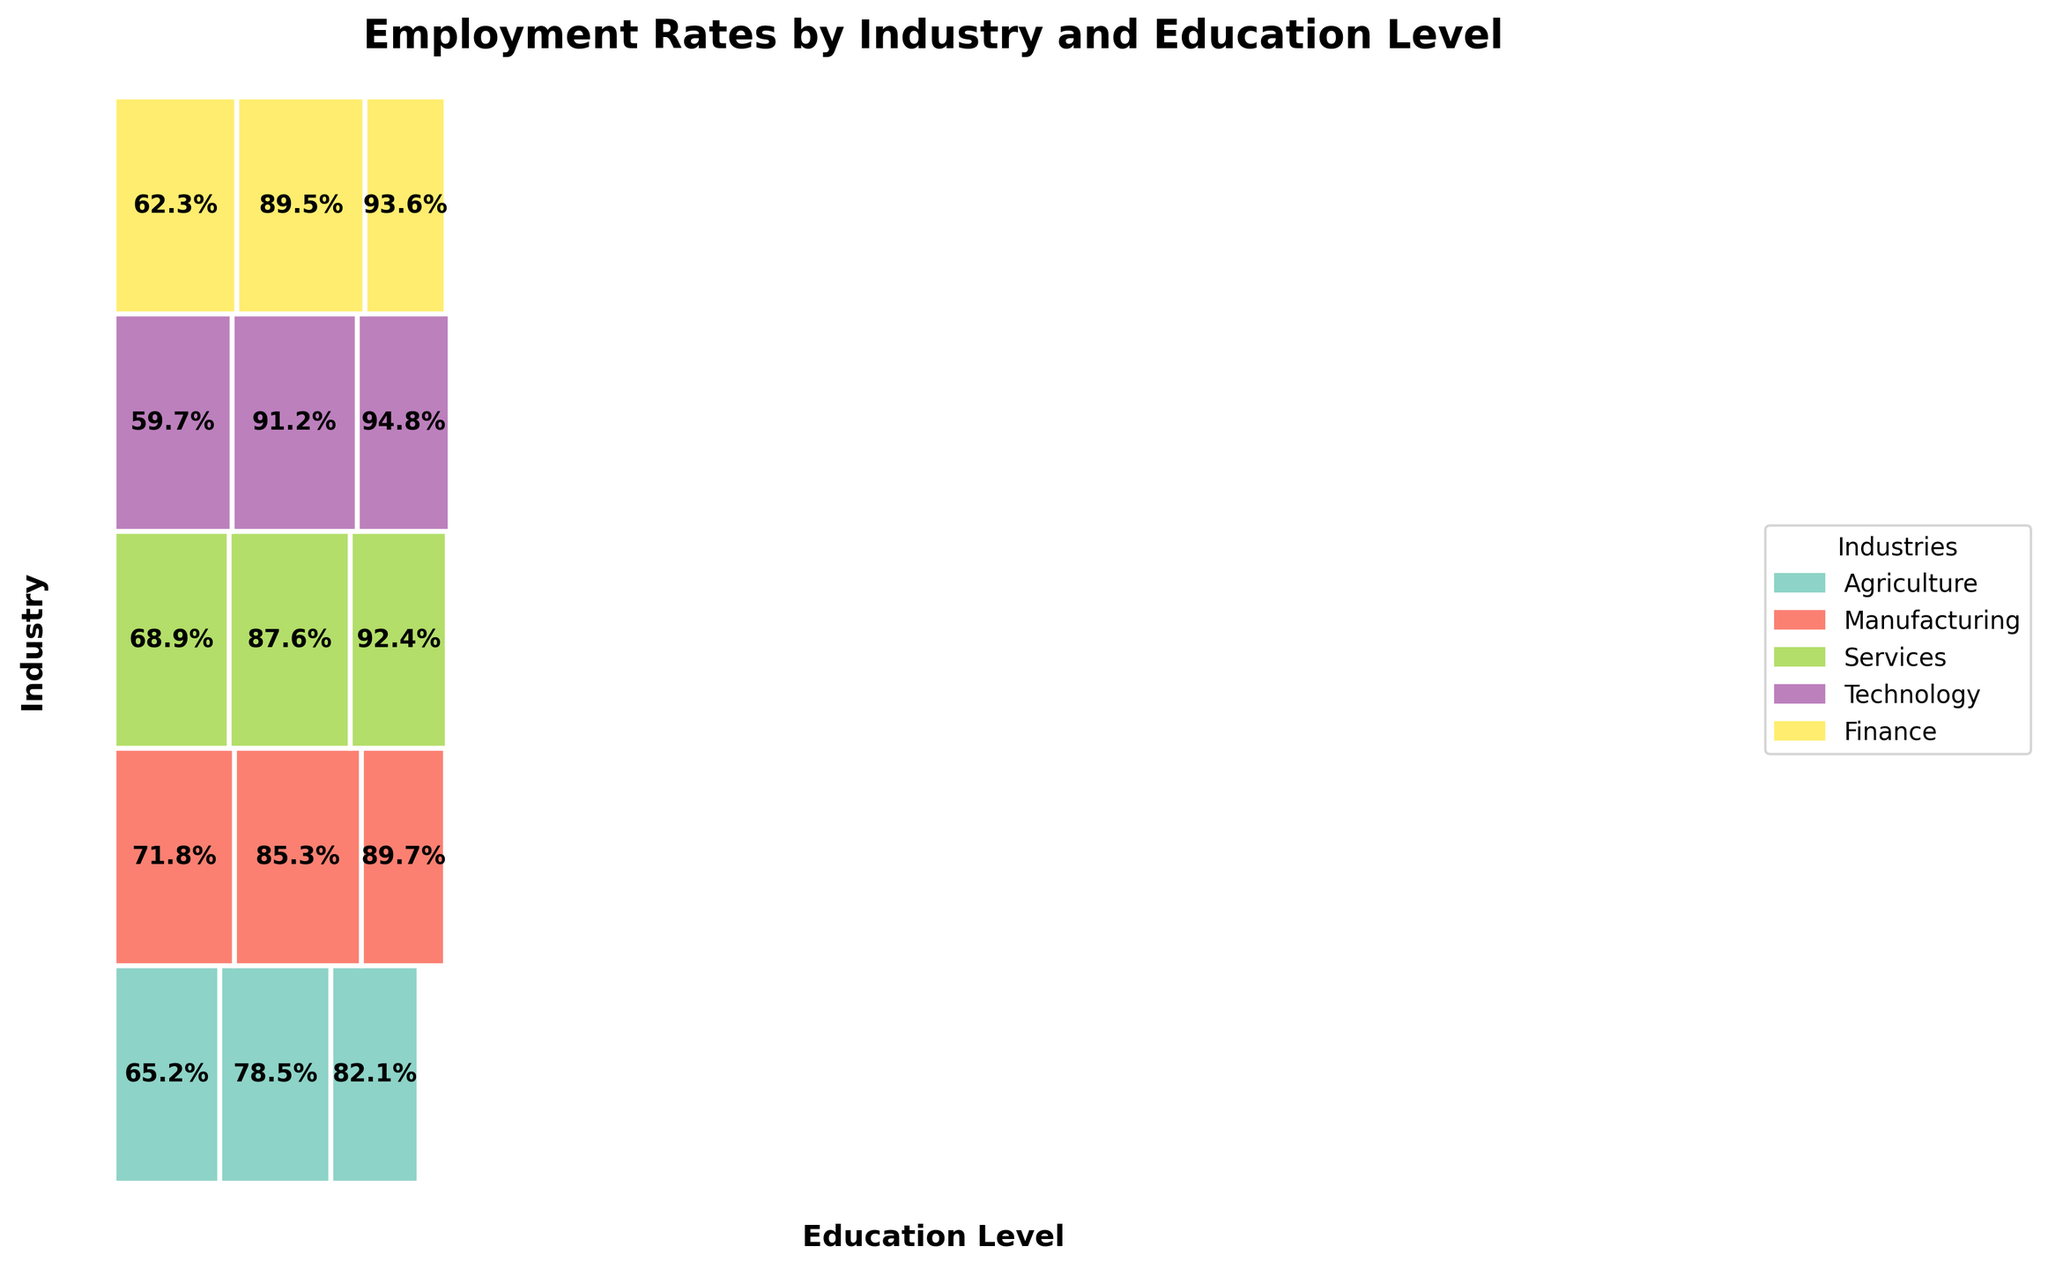What is the title of the plot? The title is located at the top of the plot in bold text. It provides a summary of what the plot represents.
Answer: Employment Rates by Industry and Education Level Which industry has the highest employment rate for high school graduates? To find this, locate the section for high school graduates and compare the employment rates across different industries, identifying the highest value.
Answer: Manufacturing What is the approximate width of the section for Bachelor's degree in Technology? Find the rectangle corresponding to the Technology industry and Bachelor's degree. The width represents the proportion of employment rate for this category.
Answer: ~0.0912 Which education level has consistently higher employment rates across all industries? Compare the employment rates across all industries for each education level. Look for the level with the highest values in each industry.
Answer: Graduate Which industry shows the greatest improvement in employment rates from high school to graduate education? For this, calculate the difference in employment rates for each industry from high school to graduate education, and identify the industry with the largest increase.
Answer: Technology How do employment rates for Bachelor's degree holders in Finance compare to those in Services? Look at the employment rates given for Bachelor's degree holders in Finance and Services. Compare their values directly.
Answer: Finance: 89.5%, Services: 87.6% What is the combined employment rate for Bachelor's and Graduate degrees in Agriculture? Sum the employment rates for Bachelor's and Graduate degrees within the Agriculture industry to get the combined rate.
Answer: 78.5% + 82.1% = 160.6% Which education level provides the lowest employment rate in the Technology industry? In the Technology industry section, compare employment rates for high school, Bachelor's, and Graduate levels. Identify the lowest value.
Answer: High School Between Manufacturing and Services industries, which has better employment rates for high school graduates? Compare the employment rates for high school graduates in Manufacturing and Services industries.
Answer: Manufacturing: 71.8%, Services: 68.9% Is there any industry where the employment rate for Bachelor's degree holders is higher than the employment rate for Graduate degree holders in another industry? Compare the employment rates for Bachelor's degree holders in every industry against the employment rates for Graduate degree holders in other industries. Identify if such a case exists.
Answer: Yes, for example, Bachelor's in Technology (91.2%) is higher than Graduate in Agriculture (82.1%) 